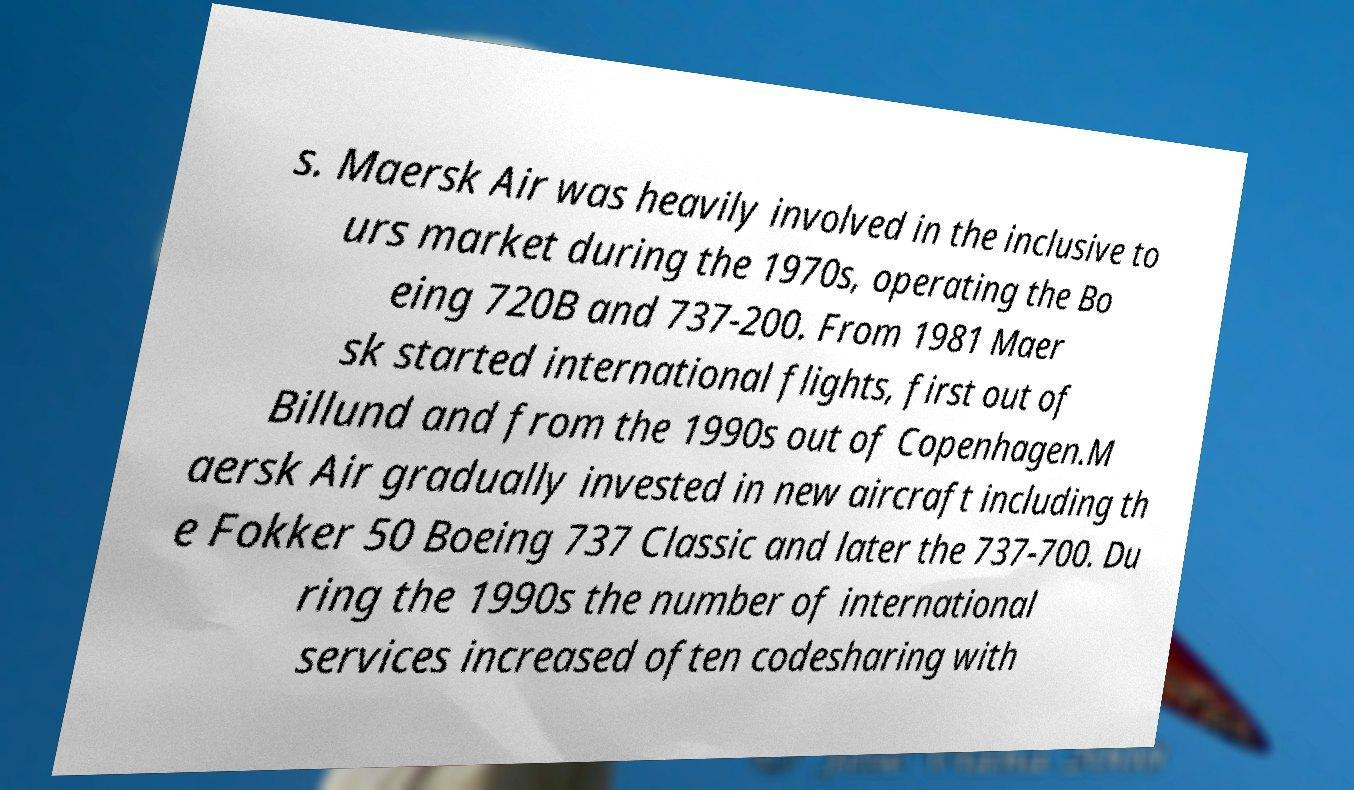There's text embedded in this image that I need extracted. Can you transcribe it verbatim? s. Maersk Air was heavily involved in the inclusive to urs market during the 1970s, operating the Bo eing 720B and 737-200. From 1981 Maer sk started international flights, first out of Billund and from the 1990s out of Copenhagen.M aersk Air gradually invested in new aircraft including th e Fokker 50 Boeing 737 Classic and later the 737-700. Du ring the 1990s the number of international services increased often codesharing with 